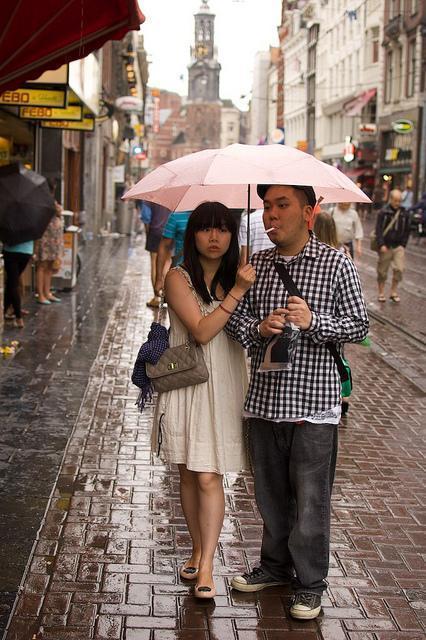How many umbrellas are in the picture?
Give a very brief answer. 2. How many people are there?
Give a very brief answer. 4. 